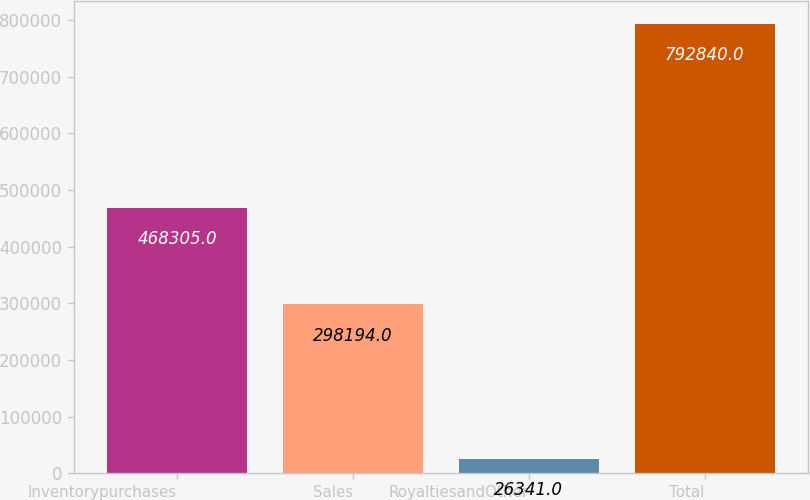<chart> <loc_0><loc_0><loc_500><loc_500><bar_chart><fcel>Inventorypurchases<fcel>Sales<fcel>RoyaltiesandOther<fcel>Total<nl><fcel>468305<fcel>298194<fcel>26341<fcel>792840<nl></chart> 